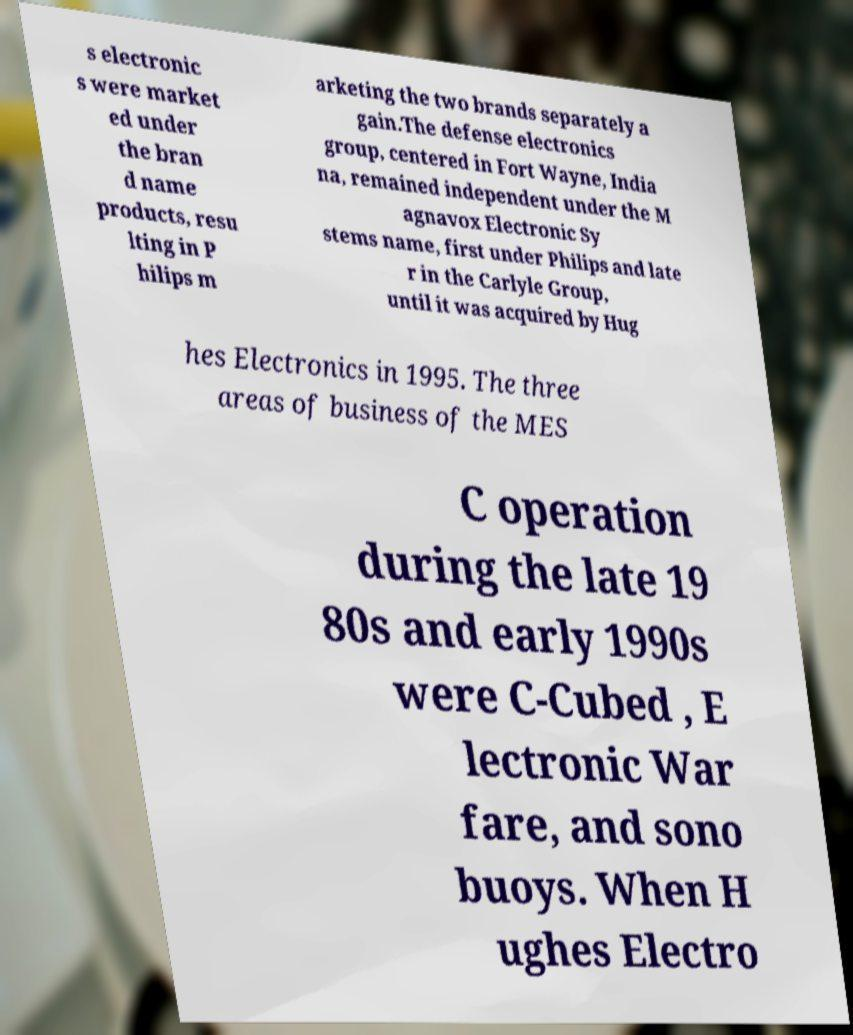Could you extract and type out the text from this image? s electronic s were market ed under the bran d name products, resu lting in P hilips m arketing the two brands separately a gain.The defense electronics group, centered in Fort Wayne, India na, remained independent under the M agnavox Electronic Sy stems name, first under Philips and late r in the Carlyle Group, until it was acquired by Hug hes Electronics in 1995. The three areas of business of the MES C operation during the late 19 80s and early 1990s were C-Cubed , E lectronic War fare, and sono buoys. When H ughes Electro 